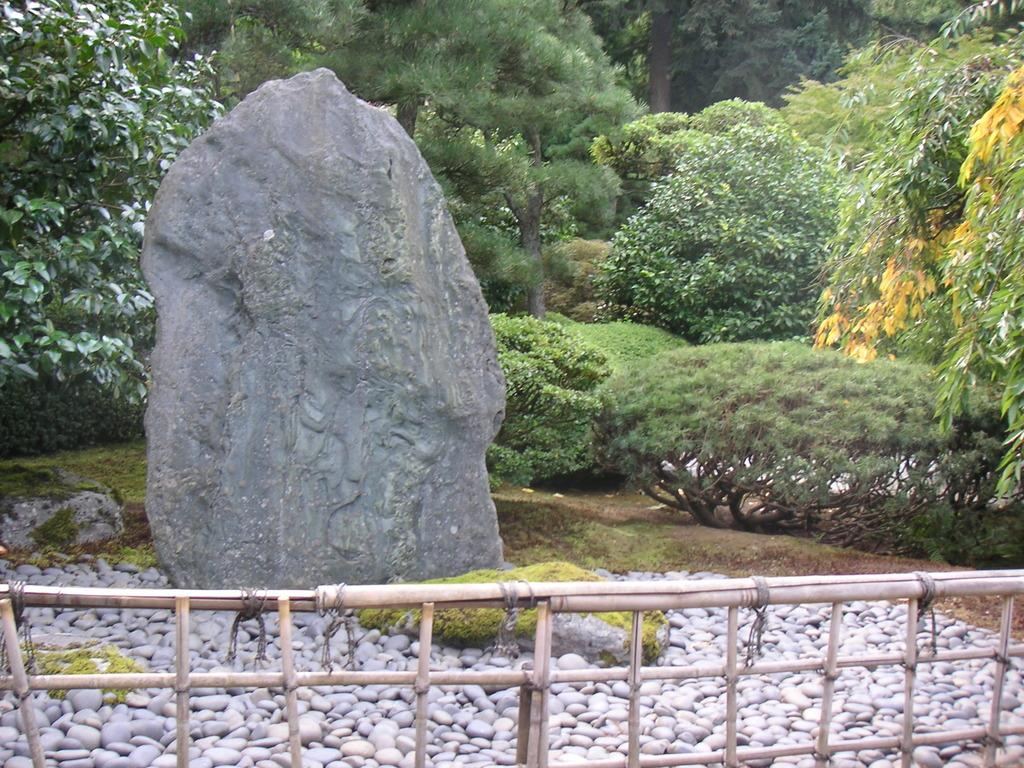What is the main subject in the image? There is a rock in the image. Are there any other rocks visible in the image? Yes, there are small rocks in the image. What is located in front of the rock? There is a fence in front of the rock. What can be seen in the background of the image? There are trees in the background of the image. How do the children react to the feather in the image? There are no children or feathers present in the image. 